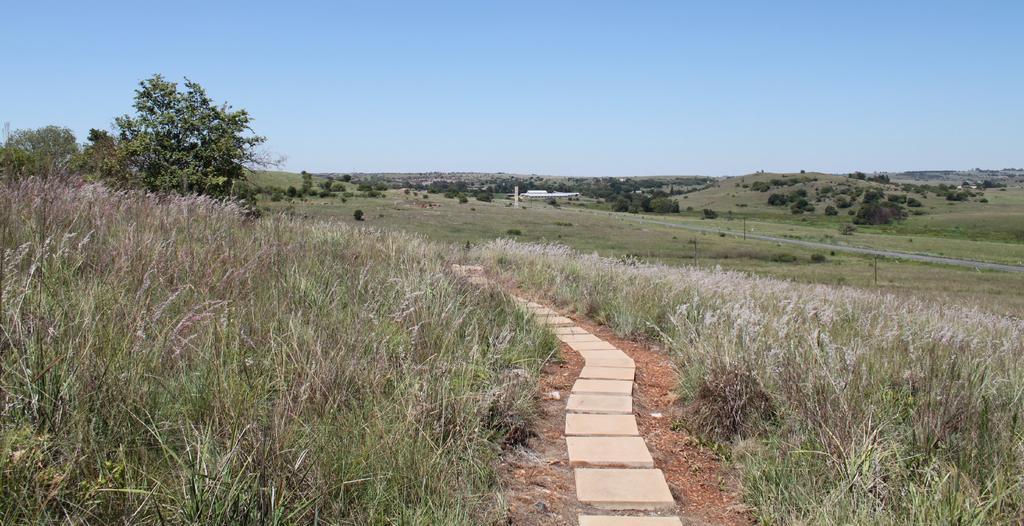Can you describe this image briefly? In this image I can see the path, few rocks on the path, few plants on both sides of the path which are green, brown and cream in color. In the background I can see few trees, a white colored building, few poles and the sky. 